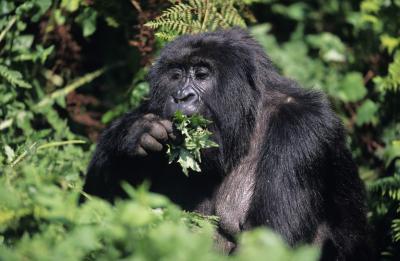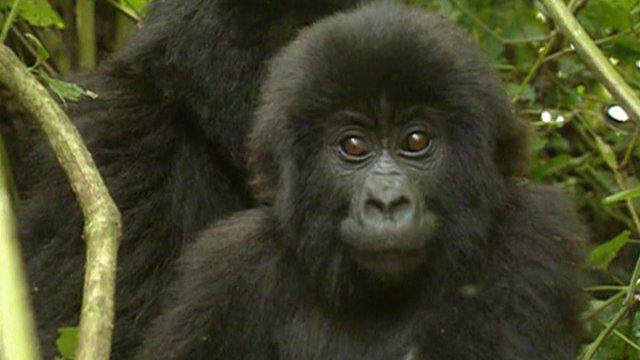The first image is the image on the left, the second image is the image on the right. Given the left and right images, does the statement "The right image contains one gorilla, an adult male with its arms extended down to the ground in front of its body." hold true? Answer yes or no. No. 